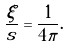Convert formula to latex. <formula><loc_0><loc_0><loc_500><loc_500>\frac { \xi } { s } = \frac { 1 } { 4 \pi } .</formula> 